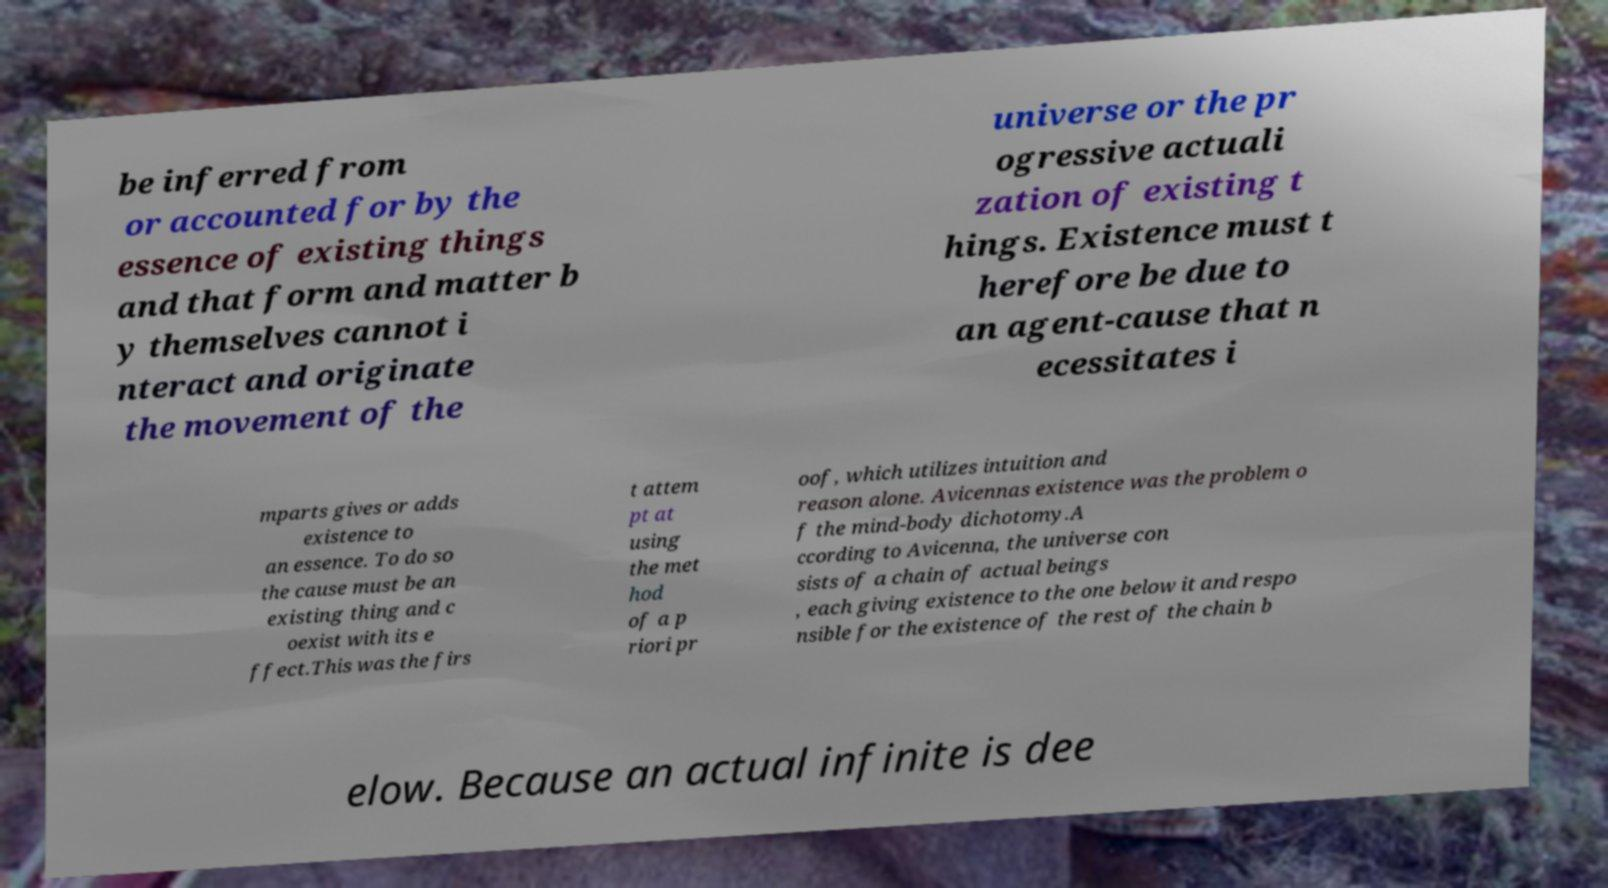Can you accurately transcribe the text from the provided image for me? be inferred from or accounted for by the essence of existing things and that form and matter b y themselves cannot i nteract and originate the movement of the universe or the pr ogressive actuali zation of existing t hings. Existence must t herefore be due to an agent-cause that n ecessitates i mparts gives or adds existence to an essence. To do so the cause must be an existing thing and c oexist with its e ffect.This was the firs t attem pt at using the met hod of a p riori pr oof, which utilizes intuition and reason alone. Avicennas existence was the problem o f the mind-body dichotomy.A ccording to Avicenna, the universe con sists of a chain of actual beings , each giving existence to the one below it and respo nsible for the existence of the rest of the chain b elow. Because an actual infinite is dee 